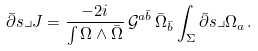<formula> <loc_0><loc_0><loc_500><loc_500>\bar { \partial } s \lrcorner J = \frac { - 2 i } { \int \Omega \wedge \bar { \Omega } } \, \mathcal { G } ^ { a \bar { b } } \, \bar { \Omega } _ { \bar { b } } \int _ { \Sigma } \bar { \partial } s \lrcorner \Omega _ { a } \, .</formula> 